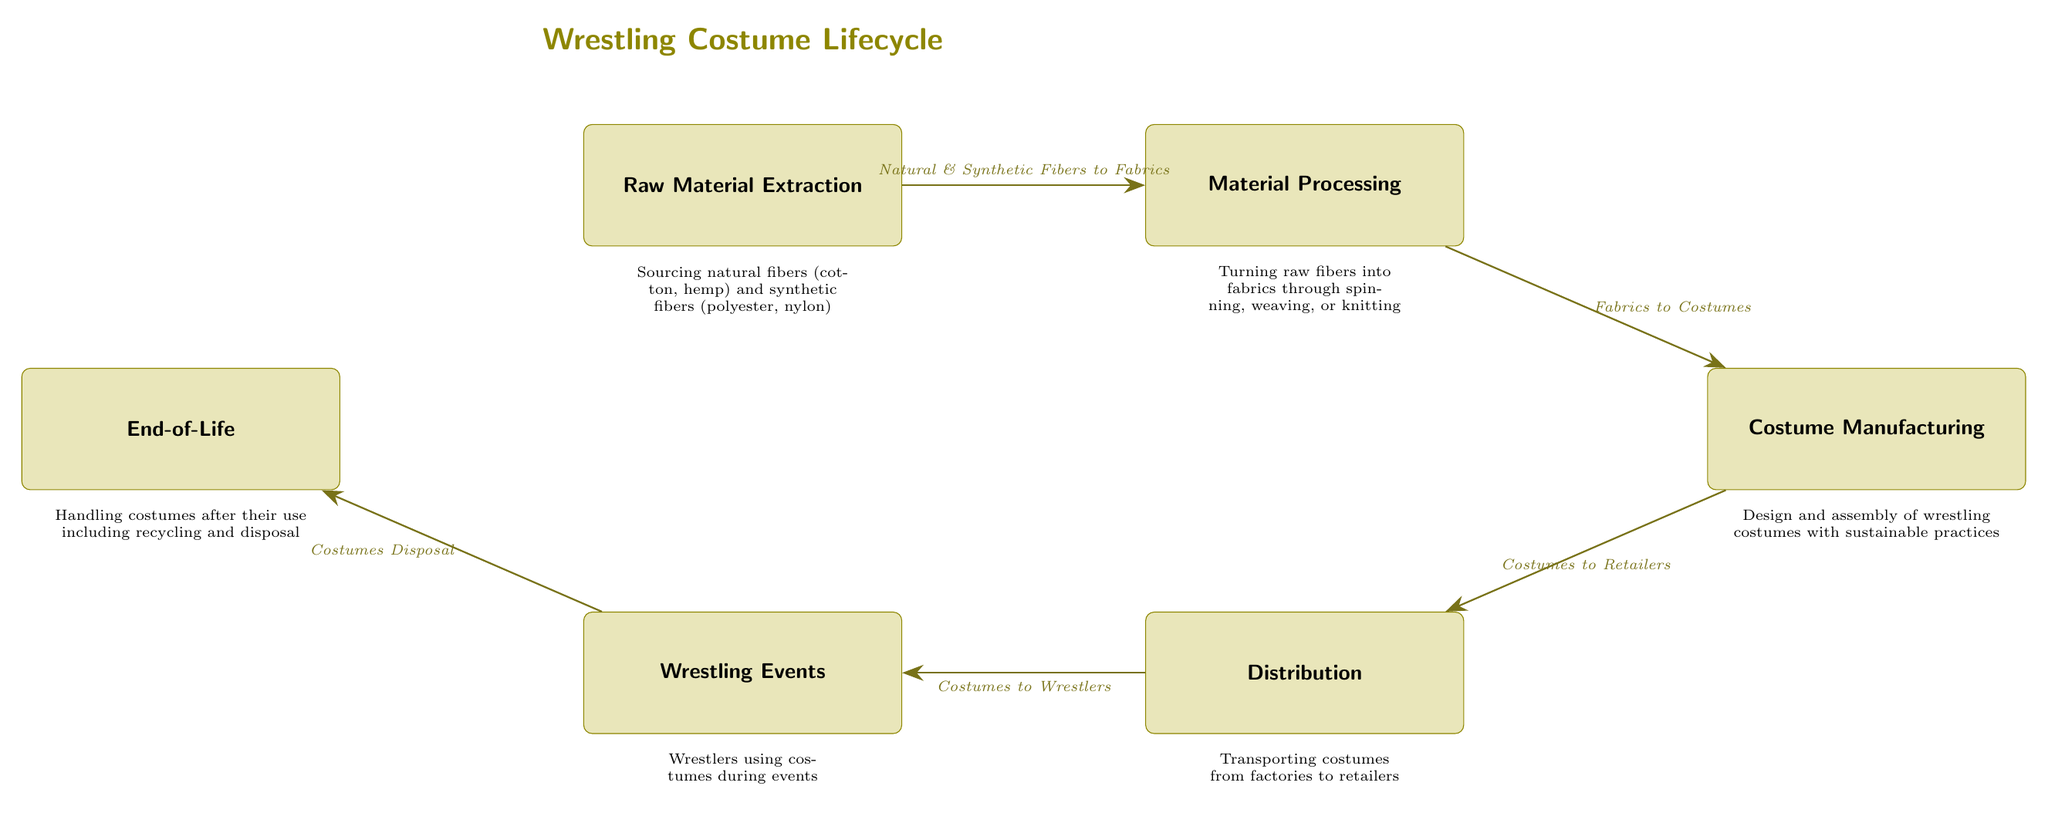What is the first step in the wrestling costume lifecycle? The diagram shows that the first step is "Raw Material Extraction," indicating it is the initial stage in the lifecycle where materials are sourced.
Answer: Raw Material Extraction Which node represents the process of turning fibers into fabrics? The diagram indicates that "Material Processing" is responsible for taking raw fibers and converting them into usable fabrics.
Answer: Material Processing How many main nodes are present in the diagram? By counting the nodes from "Raw Material Extraction" to "End-of-Life," there are a total of six main nodes in the diagram.
Answer: 6 What connects the nodes "Distribution" and "Wrestling Events"? The diagram specifies that "Costumes to Wrestlers" is the relationship that illustrates the flow between "Distribution" and "Wrestling Events."
Answer: Costumes to Wrestlers What is the last step in the lifecycle of wrestling costumes? According to the diagram, the final step is "End-of-Life," which represents the stages handling costumes after their usage, such as recycling or disposal.
Answer: End-of-Life Which type of materials are included in the "Raw Material Extraction" phase? The diagram identifies that this phase includes "Natural & Synthetic Fibers," specifying the different types of materials sourced at the beginning of the lifecycle.
Answer: Natural & Synthetic Fibers Which process immediately follows "Material Processing"? The diagram indicates that the "Costume Manufacturing" phase comes directly after "Material Processing," representing the design and assembly of costumes.
Answer: Costume Manufacturing What process occurs to costumes after they are used by wrestlers? The diagram states that after wrestlers use the costumes, they go through the "Costumes Disposal" phase, which deals with the end-of-life management of the costumes.
Answer: Costumes Disposal 